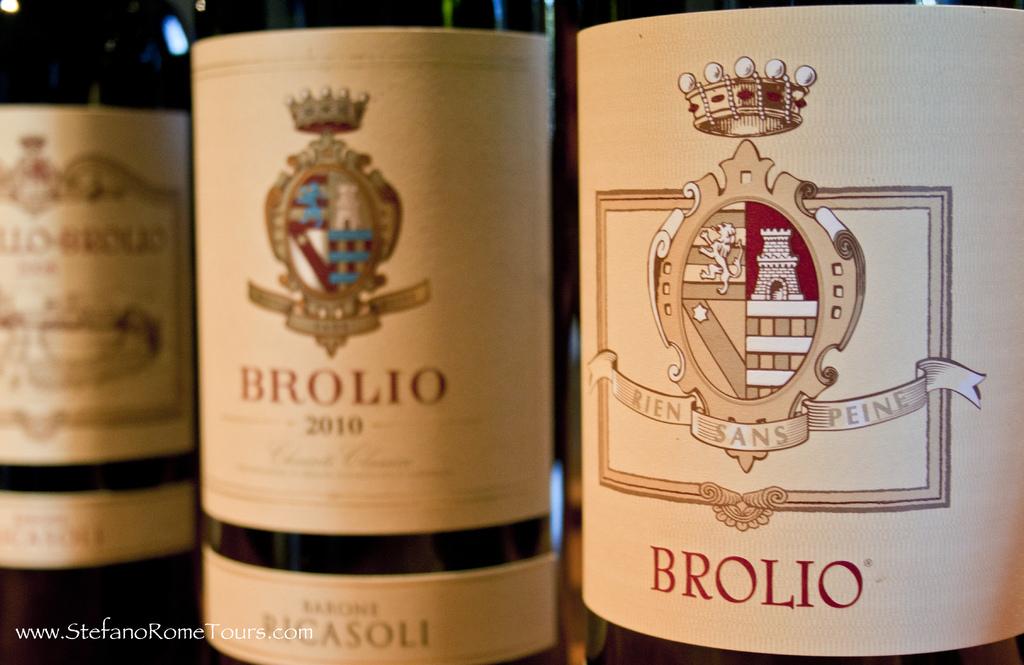What year is the bottle in the middle?
Your answer should be compact. 2010. What brand is written on the bottle on the right?
Ensure brevity in your answer.  Brolio. 